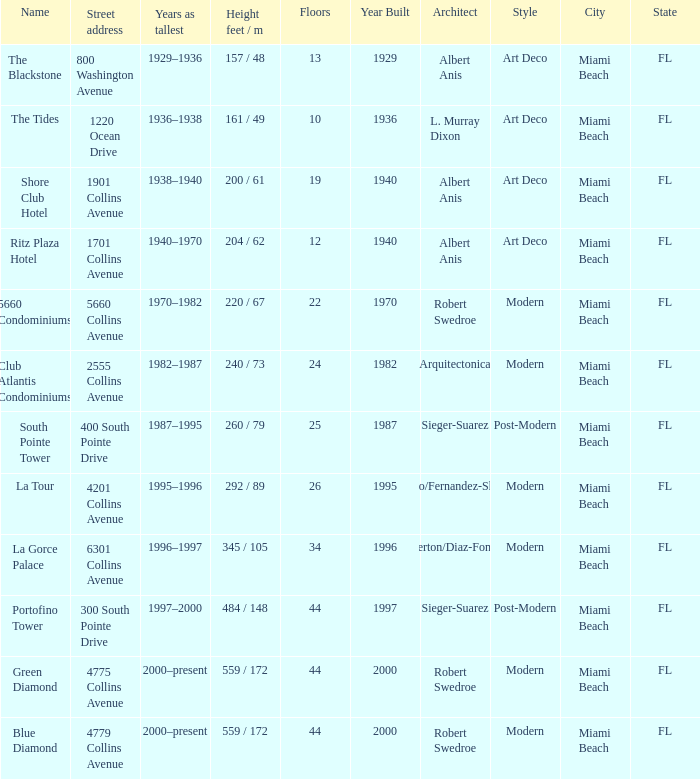How many floors does the Blue Diamond have? 44.0. 